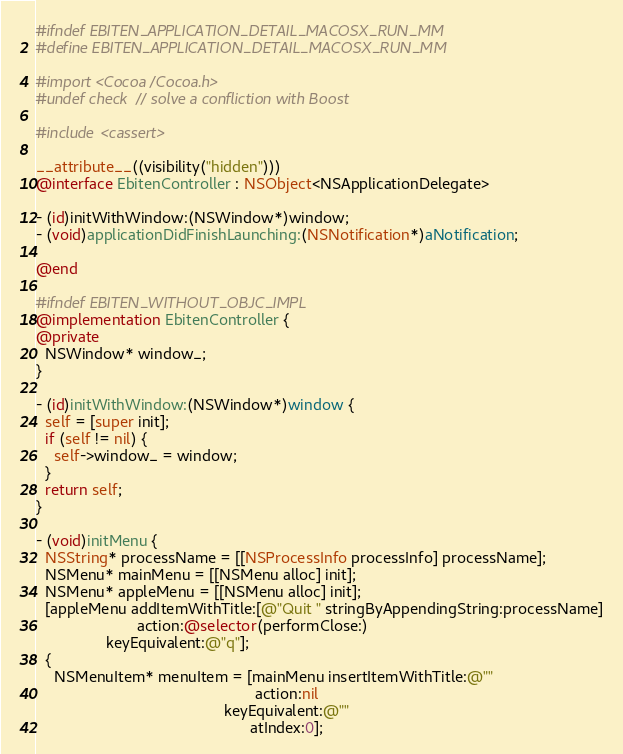Convert code to text. <code><loc_0><loc_0><loc_500><loc_500><_ObjectiveC_>#ifndef EBITEN_APPLICATION_DETAIL_MACOSX_RUN_MM
#define EBITEN_APPLICATION_DETAIL_MACOSX_RUN_MM

#import <Cocoa/Cocoa.h>
#undef check // solve a confliction with Boost

#include <cassert>

__attribute__((visibility("hidden")))
@interface EbitenController : NSObject<NSApplicationDelegate>

- (id)initWithWindow:(NSWindow*)window;
- (void)applicationDidFinishLaunching:(NSNotification*)aNotification;

@end

#ifndef EBITEN_WITHOUT_OBJC_IMPL
@implementation EbitenController {
@private
  NSWindow* window_;
}

- (id)initWithWindow:(NSWindow*)window {
  self = [super init];
  if (self != nil) {
    self->window_ = window;
  }
  return self;
}

- (void)initMenu {
  NSString* processName = [[NSProcessInfo processInfo] processName];
  NSMenu* mainMenu = [[NSMenu alloc] init];
  NSMenu* appleMenu = [[NSMenu alloc] init];
  [appleMenu addItemWithTitle:[@"Quit " stringByAppendingString:processName]
                       action:@selector(performClose:)
                keyEquivalent:@"q"];
  {
    NSMenuItem* menuItem = [mainMenu insertItemWithTitle:@""
                                                  action:nil
                                           keyEquivalent:@""
                                                 atIndex:0];</code> 